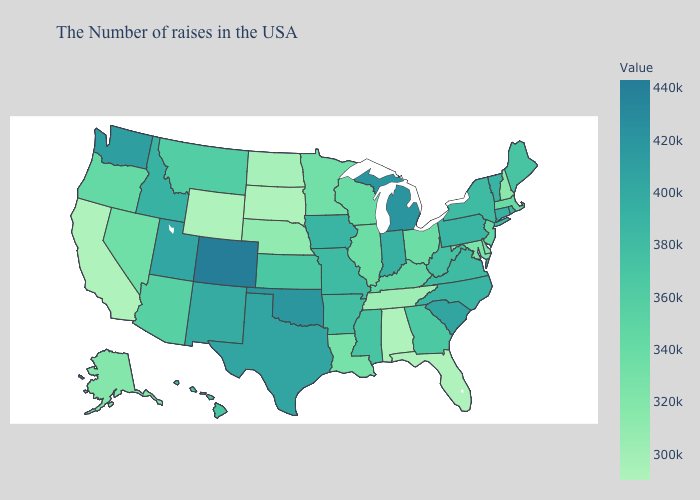Which states have the highest value in the USA?
Answer briefly. Colorado. Among the states that border Massachusetts , does Vermont have the lowest value?
Concise answer only. No. Which states hav the highest value in the MidWest?
Answer briefly. Michigan. Among the states that border New Jersey , does Pennsylvania have the lowest value?
Concise answer only. No. Among the states that border Florida , which have the highest value?
Be succinct. Georgia. Does Florida have the lowest value in the USA?
Short answer required. Yes. 